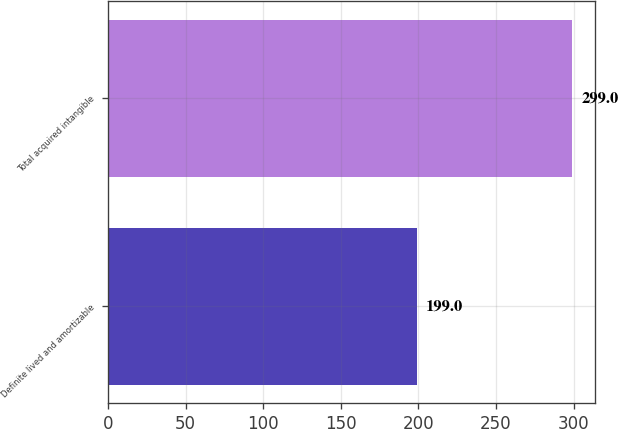Convert chart. <chart><loc_0><loc_0><loc_500><loc_500><bar_chart><fcel>Definite lived and amortizable<fcel>Total acquired intangible<nl><fcel>199<fcel>299<nl></chart> 